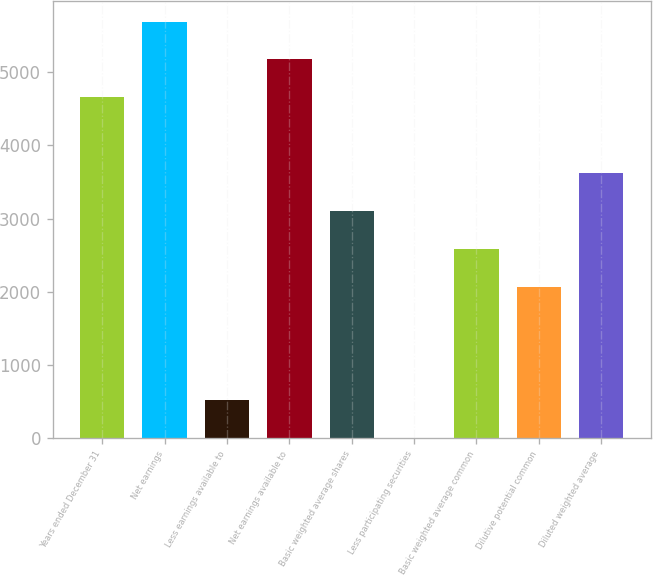<chart> <loc_0><loc_0><loc_500><loc_500><bar_chart><fcel>Years ended December 31<fcel>Net earnings<fcel>Less earnings available to<fcel>Net earnings available to<fcel>Basic weighted average shares<fcel>Less participating securities<fcel>Basic weighted average common<fcel>Dilutive potential common<fcel>Diluted weighted average<nl><fcel>4658.51<fcel>5693.49<fcel>518.59<fcel>5176<fcel>3106.04<fcel>1.1<fcel>2588.55<fcel>2071.06<fcel>3623.53<nl></chart> 